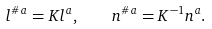<formula> <loc_0><loc_0><loc_500><loc_500>l ^ { \# \, a } = K l ^ { a } , \quad n ^ { \# \, a } = K ^ { - 1 } n ^ { a } .</formula> 